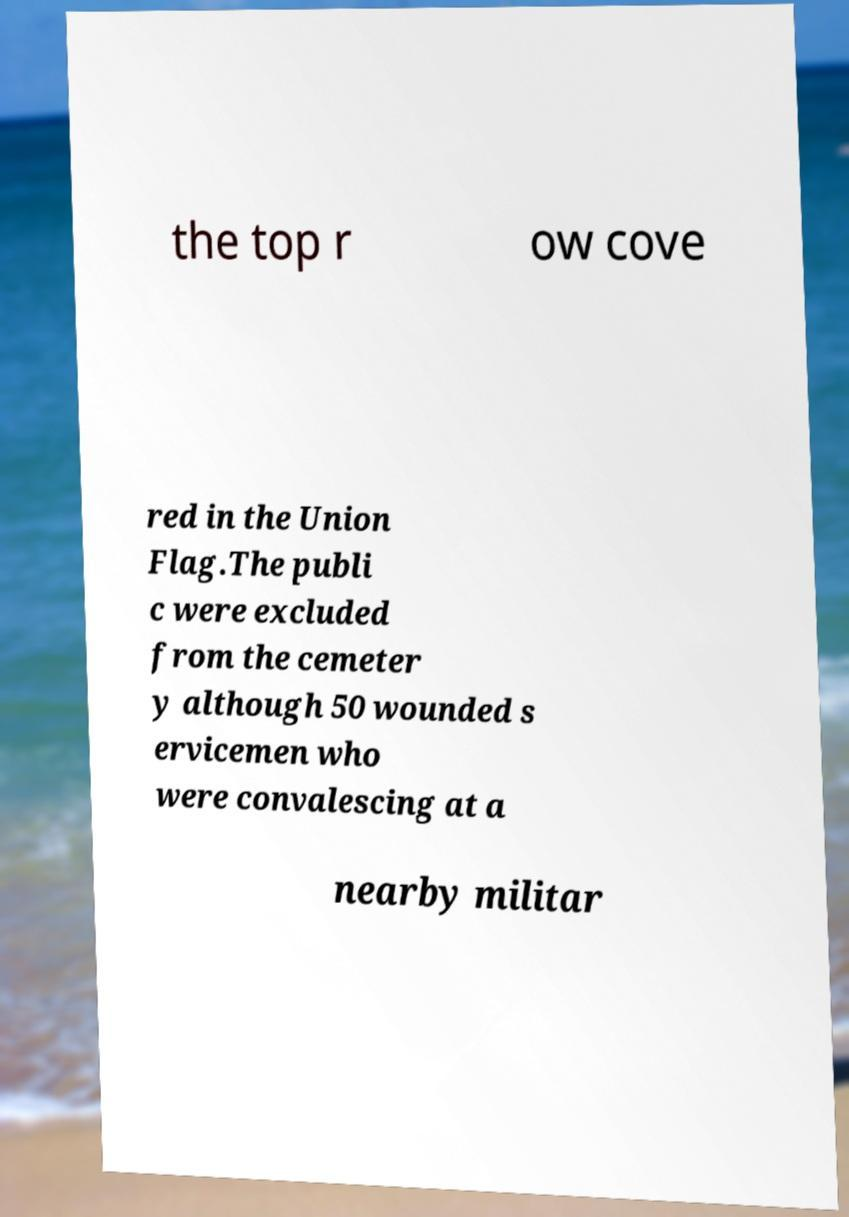Could you assist in decoding the text presented in this image and type it out clearly? the top r ow cove red in the Union Flag.The publi c were excluded from the cemeter y although 50 wounded s ervicemen who were convalescing at a nearby militar 